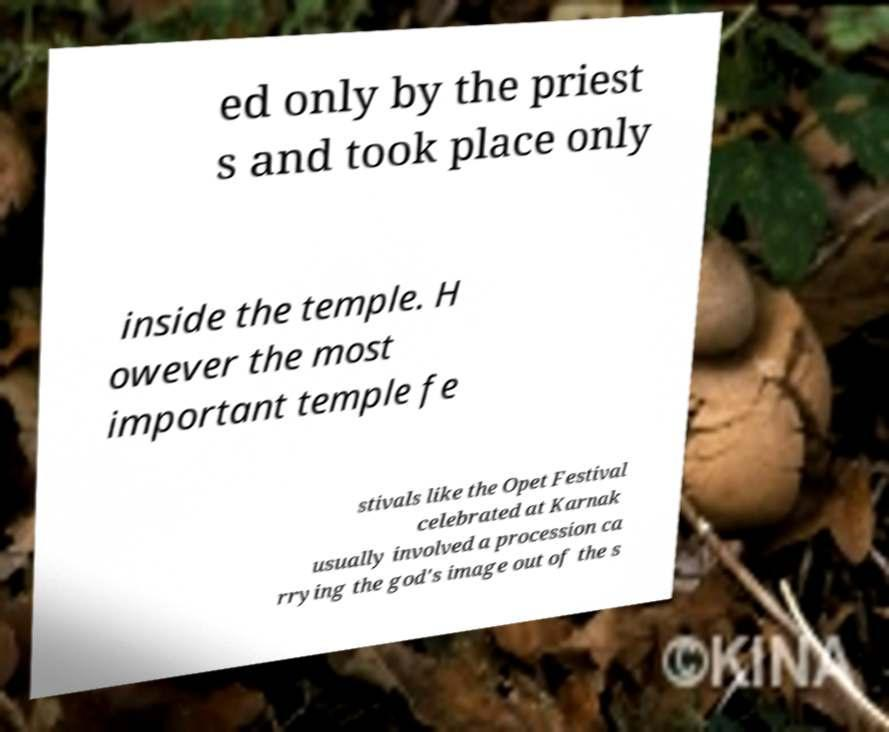For documentation purposes, I need the text within this image transcribed. Could you provide that? ed only by the priest s and took place only inside the temple. H owever the most important temple fe stivals like the Opet Festival celebrated at Karnak usually involved a procession ca rrying the god's image out of the s 